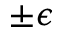Convert formula to latex. <formula><loc_0><loc_0><loc_500><loc_500>\pm \epsilon</formula> 